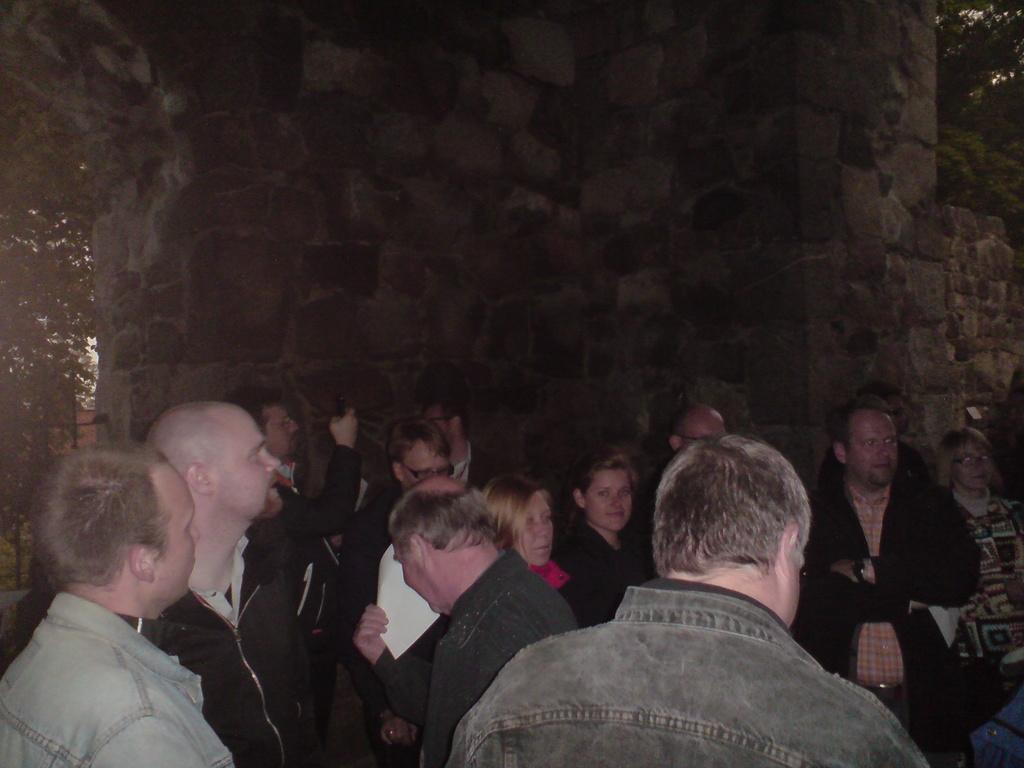How many people are in the image? There is a group of persons in the image, but the exact number cannot be determined from the provided facts. What is located behind the persons in the image? There is a wall visible behind the persons in the image. What type of vegetation can be seen on the left side of the image? There is a tree on the left side of the image. Can you describe the vegetation visible in the top right of the image? There is another tree visible in the top right of the image. What type of pencil can be seen in the hands of the persons in the image? There is no pencil present in the image; the persons are not holding any writing instruments. How many zebras are visible in the image? There are no zebras present in the image. 